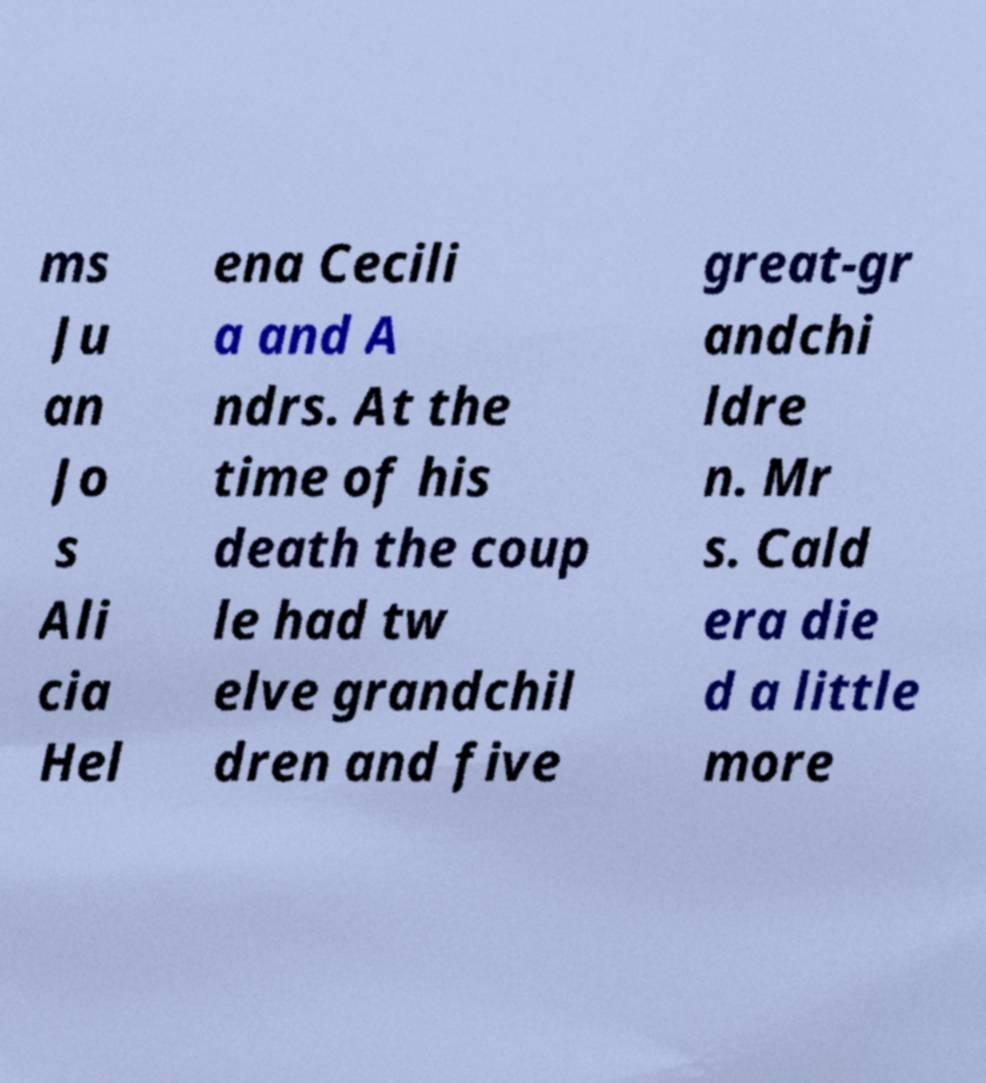Could you extract and type out the text from this image? ms Ju an Jo s Ali cia Hel ena Cecili a and A ndrs. At the time of his death the coup le had tw elve grandchil dren and five great-gr andchi ldre n. Mr s. Cald era die d a little more 